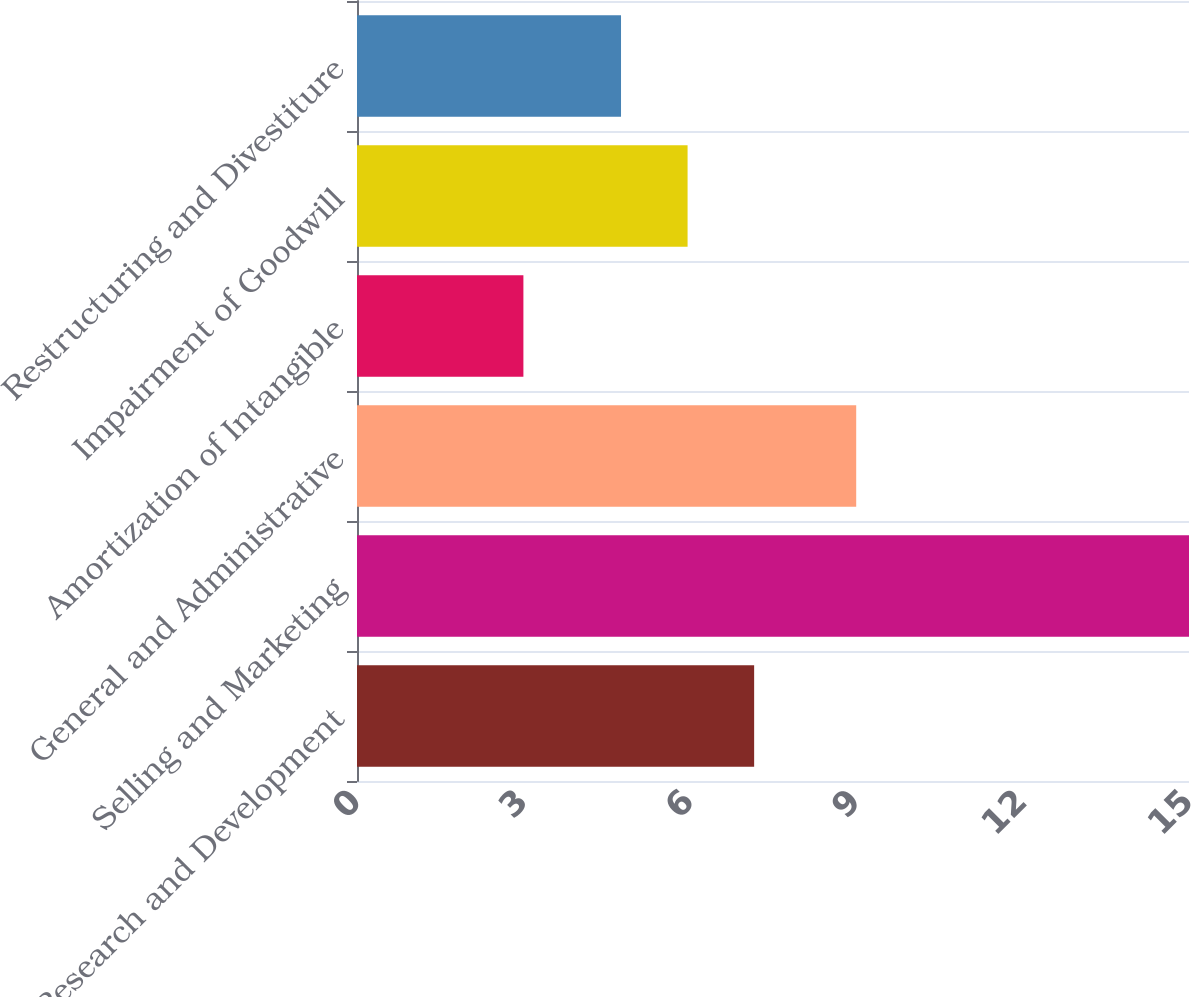Convert chart. <chart><loc_0><loc_0><loc_500><loc_500><bar_chart><fcel>Research and Development<fcel>Selling and Marketing<fcel>General and Administrative<fcel>Amortization of Intangible<fcel>Impairment of Goodwill<fcel>Restructuring and Divestiture<nl><fcel>7.16<fcel>15<fcel>9<fcel>3<fcel>5.96<fcel>4.76<nl></chart> 